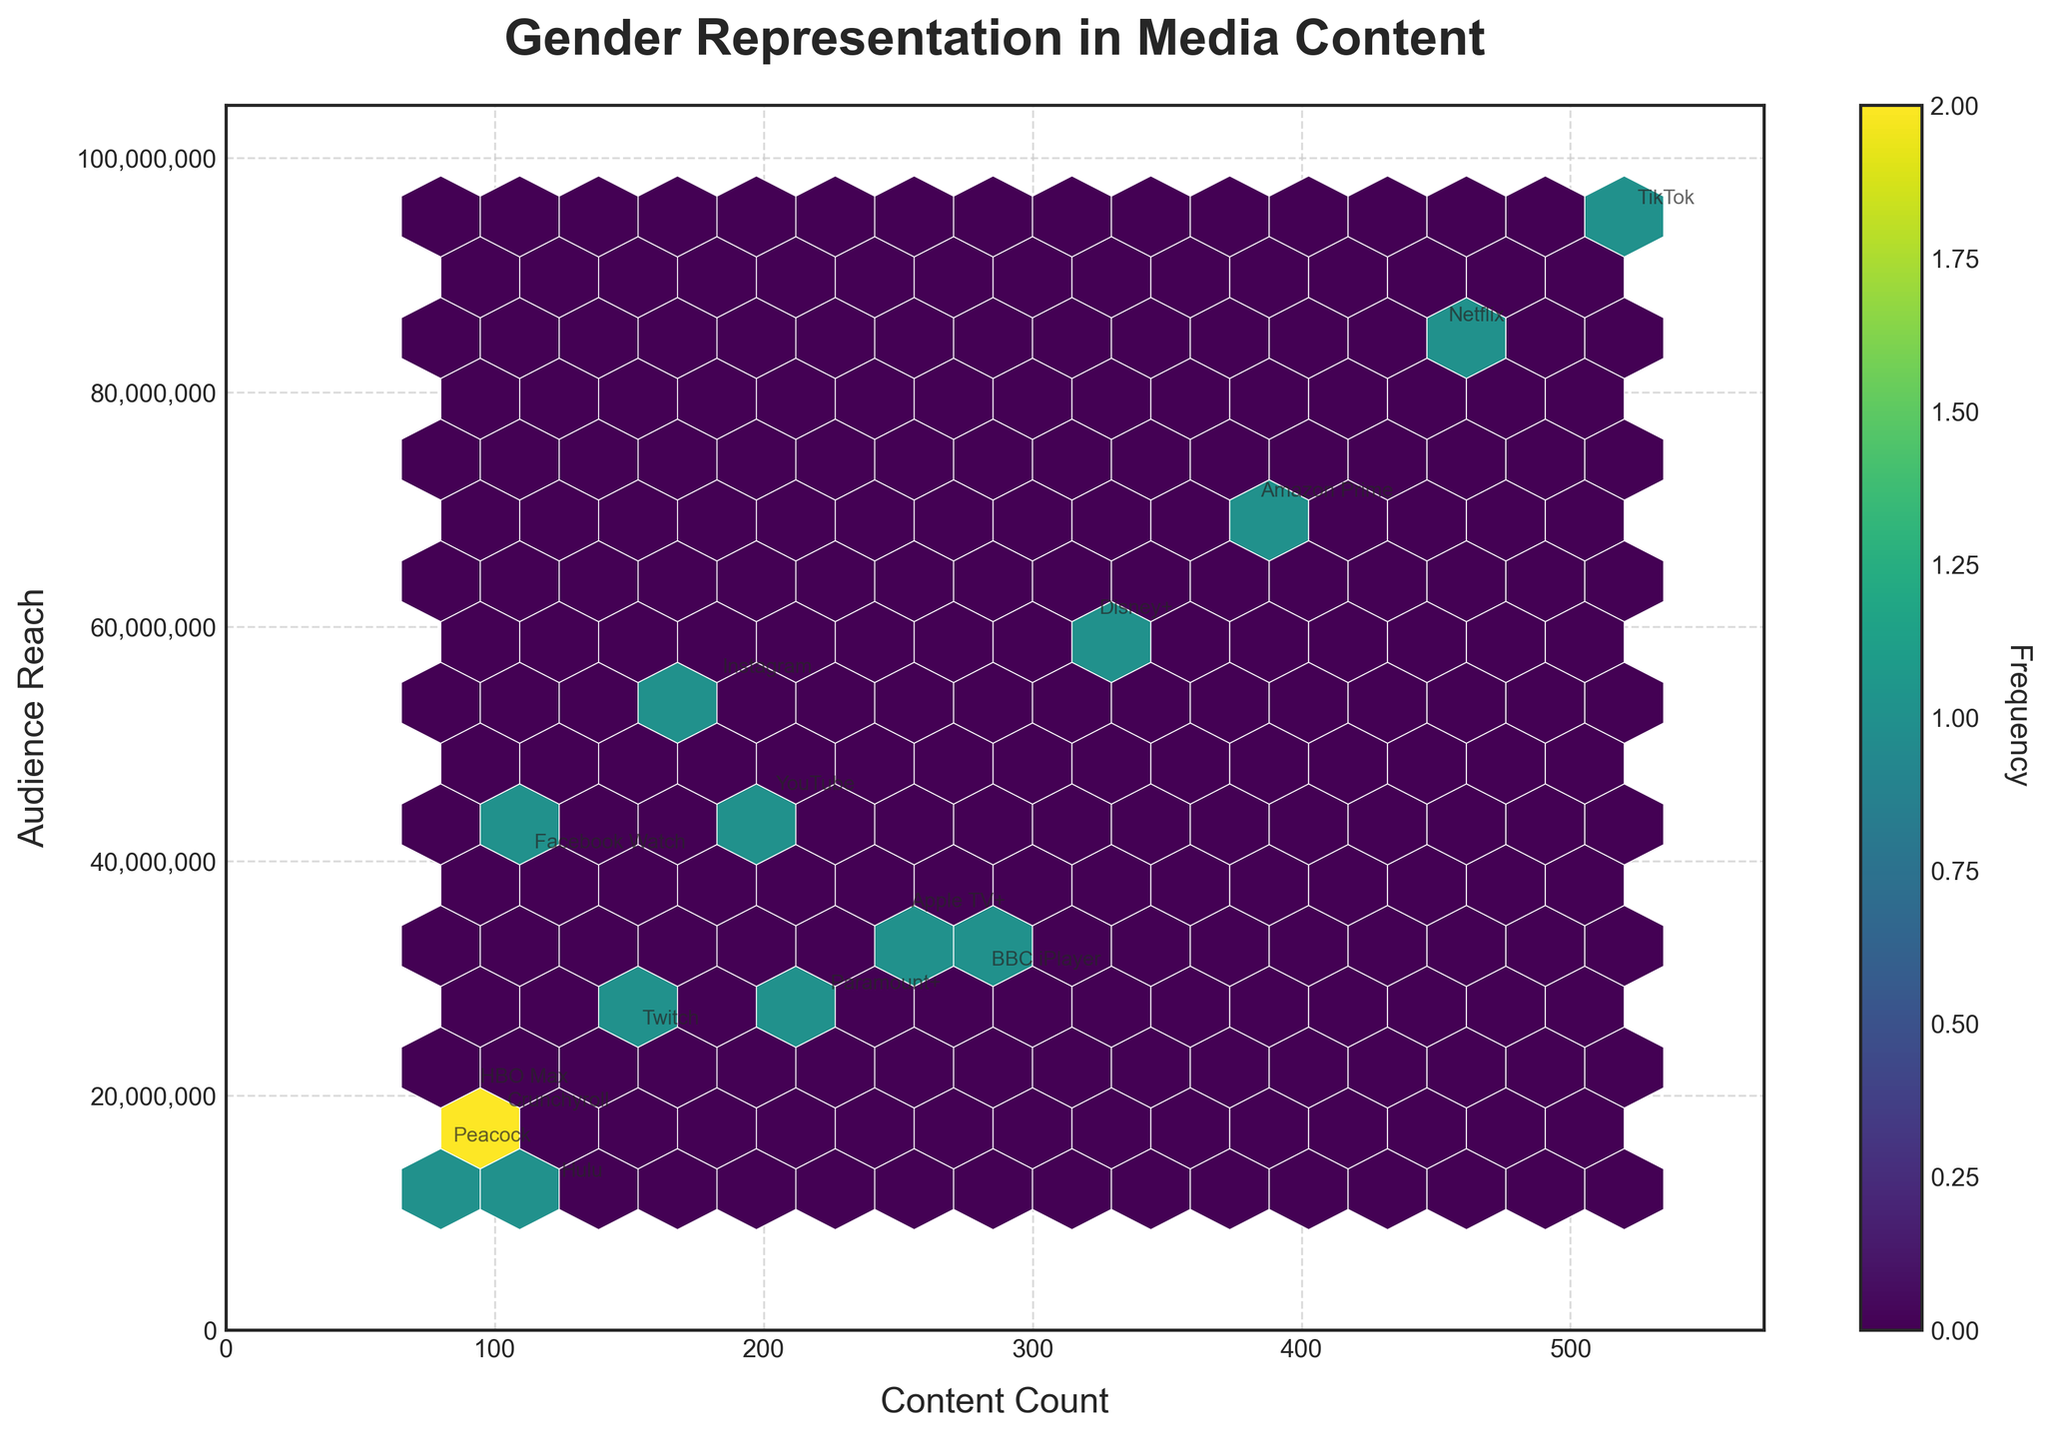What is the title of the plot? The plot's title is located at the top of the figure and is prominently displayed. By examining the figure, it is clear that it is titled "Gender Representation in Media Content."
Answer: Gender Representation in Media Content How many platforms are represented in the plot? Each platform is annotated within the hexbin plot. By counting the different platform names, we can determine that there are 15 platforms shown in the plot.
Answer: 15 Which platform has the highest content count and what is the corresponding audience reach? By looking at the x-axis (Content Count) and finding the highest value, and then tracing that point vertically to the corresponding y-axis (Audience Reach) value, we can determine TikTok has the highest content count with 520, and its corresponding audience reach is 95,000,000.
Answer: TikTok, 95,000,000 Are there any platforms with overlapping content counts and audience reaches in the plot? To find if any platforms overlap, we examine the coordinates for each platform. Since the plot uses a hexbin format, closely overlapping points are aggregated. However, looking at the annotations, no two platforms share the exact same spot.
Answer: No Which gender identity has the highest frequency in terms of the number of content? Observing the density of hexagons and platform names annotated around it, female representation (annotated as platforms Netflix, TikTok, BBC iPlayer, Paramount+) shows higher frequency. By cross-referencing content counts with gender identity, it's easier to see that Female is the most frequently represented gender identity in media content among these platforms.
Answer: Female What is the relationship between content count and audience reach across the platforms? Examining the distribution and density of hexagons, it is evident that there's a general positive trend: platforms with higher content counts tend to have higher audience reach. This can be seen with platforms like TikTok and Netflix having both high content counts and high audience reach.
Answer: Positive correlation Between Hulu and HBO Max, which platform has a higher audience reach and by how much? By comparing the y-axis values for Hulu and HBO Max, Hulu is closer to 12,000,000 while HBO Max is at 20,000,000. Calculating the difference, HBO Max has an audience reach higher by 8,000,000.
Answer: HBO Max, by 8,000,000 Which platforms have less than 100 content count, and what are their audience reaches? Filtering for points less than 100 on the x-axis and noting the corresponding y-axis values, the platforms are: Peacock (15,000,000), Crunchyroll (18,000,000), HBO Max (20,000,000), and Hulu (12,000,000).
Answer: Peacock, Crunchyroll, HBO Max, Hulu Is there a platform that has a content count near the median range, and what is its audience reach? By ordering the content counts and finding the median value, which falls around 200. Platforms like YouTube (200) and Paramount+ (220) are close to the median. YouTube has an audience reach of 45,000,000.
Answer: YouTube, 45,000,000 